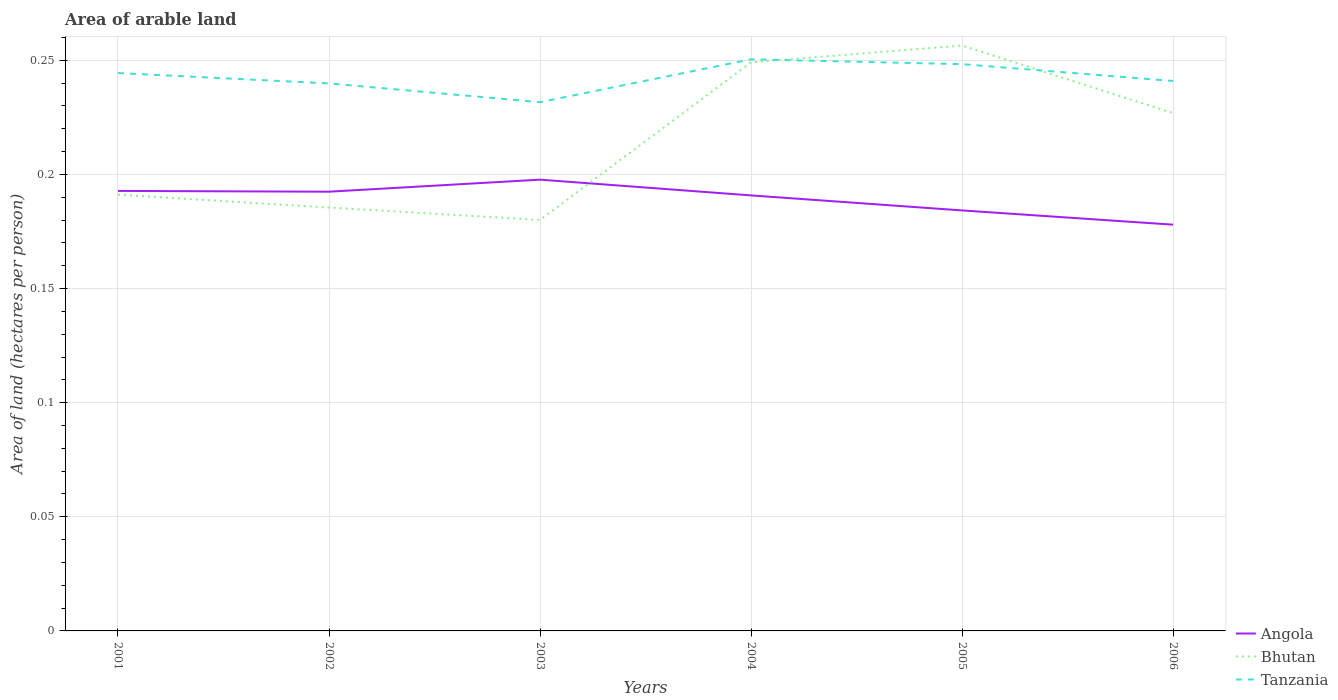Across all years, what is the maximum total arable land in Bhutan?
Your answer should be very brief. 0.18. In which year was the total arable land in Bhutan maximum?
Your answer should be compact. 2003. What is the total total arable land in Bhutan in the graph?
Keep it short and to the point. -0.08. What is the difference between the highest and the second highest total arable land in Bhutan?
Keep it short and to the point. 0.08. How many lines are there?
Offer a very short reply. 3. How many years are there in the graph?
Offer a very short reply. 6. What is the difference between two consecutive major ticks on the Y-axis?
Give a very brief answer. 0.05. Are the values on the major ticks of Y-axis written in scientific E-notation?
Provide a short and direct response. No. Where does the legend appear in the graph?
Ensure brevity in your answer.  Bottom right. How many legend labels are there?
Offer a terse response. 3. What is the title of the graph?
Give a very brief answer. Area of arable land. What is the label or title of the X-axis?
Provide a succinct answer. Years. What is the label or title of the Y-axis?
Ensure brevity in your answer.  Area of land (hectares per person). What is the Area of land (hectares per person) of Angola in 2001?
Ensure brevity in your answer.  0.19. What is the Area of land (hectares per person) in Bhutan in 2001?
Your answer should be very brief. 0.19. What is the Area of land (hectares per person) of Tanzania in 2001?
Provide a short and direct response. 0.24. What is the Area of land (hectares per person) in Angola in 2002?
Provide a succinct answer. 0.19. What is the Area of land (hectares per person) in Bhutan in 2002?
Your answer should be very brief. 0.19. What is the Area of land (hectares per person) of Tanzania in 2002?
Your answer should be compact. 0.24. What is the Area of land (hectares per person) in Angola in 2003?
Your answer should be very brief. 0.2. What is the Area of land (hectares per person) of Bhutan in 2003?
Keep it short and to the point. 0.18. What is the Area of land (hectares per person) in Tanzania in 2003?
Your answer should be compact. 0.23. What is the Area of land (hectares per person) of Angola in 2004?
Provide a short and direct response. 0.19. What is the Area of land (hectares per person) of Bhutan in 2004?
Keep it short and to the point. 0.25. What is the Area of land (hectares per person) of Tanzania in 2004?
Offer a terse response. 0.25. What is the Area of land (hectares per person) of Angola in 2005?
Your response must be concise. 0.18. What is the Area of land (hectares per person) of Bhutan in 2005?
Ensure brevity in your answer.  0.26. What is the Area of land (hectares per person) in Tanzania in 2005?
Provide a succinct answer. 0.25. What is the Area of land (hectares per person) in Angola in 2006?
Offer a terse response. 0.18. What is the Area of land (hectares per person) of Bhutan in 2006?
Keep it short and to the point. 0.23. What is the Area of land (hectares per person) of Tanzania in 2006?
Provide a succinct answer. 0.24. Across all years, what is the maximum Area of land (hectares per person) of Angola?
Make the answer very short. 0.2. Across all years, what is the maximum Area of land (hectares per person) in Bhutan?
Offer a very short reply. 0.26. Across all years, what is the maximum Area of land (hectares per person) of Tanzania?
Offer a very short reply. 0.25. Across all years, what is the minimum Area of land (hectares per person) of Angola?
Ensure brevity in your answer.  0.18. Across all years, what is the minimum Area of land (hectares per person) of Bhutan?
Provide a succinct answer. 0.18. Across all years, what is the minimum Area of land (hectares per person) of Tanzania?
Make the answer very short. 0.23. What is the total Area of land (hectares per person) in Angola in the graph?
Your answer should be very brief. 1.14. What is the total Area of land (hectares per person) of Bhutan in the graph?
Keep it short and to the point. 1.29. What is the total Area of land (hectares per person) of Tanzania in the graph?
Provide a succinct answer. 1.46. What is the difference between the Area of land (hectares per person) of Bhutan in 2001 and that in 2002?
Your answer should be compact. 0.01. What is the difference between the Area of land (hectares per person) in Tanzania in 2001 and that in 2002?
Give a very brief answer. 0. What is the difference between the Area of land (hectares per person) in Angola in 2001 and that in 2003?
Provide a succinct answer. -0. What is the difference between the Area of land (hectares per person) of Bhutan in 2001 and that in 2003?
Offer a terse response. 0.01. What is the difference between the Area of land (hectares per person) in Tanzania in 2001 and that in 2003?
Offer a terse response. 0.01. What is the difference between the Area of land (hectares per person) of Angola in 2001 and that in 2004?
Offer a terse response. 0. What is the difference between the Area of land (hectares per person) of Bhutan in 2001 and that in 2004?
Your answer should be compact. -0.06. What is the difference between the Area of land (hectares per person) of Tanzania in 2001 and that in 2004?
Keep it short and to the point. -0.01. What is the difference between the Area of land (hectares per person) in Angola in 2001 and that in 2005?
Give a very brief answer. 0.01. What is the difference between the Area of land (hectares per person) in Bhutan in 2001 and that in 2005?
Your answer should be very brief. -0.07. What is the difference between the Area of land (hectares per person) in Tanzania in 2001 and that in 2005?
Provide a succinct answer. -0. What is the difference between the Area of land (hectares per person) in Angola in 2001 and that in 2006?
Provide a short and direct response. 0.01. What is the difference between the Area of land (hectares per person) in Bhutan in 2001 and that in 2006?
Your response must be concise. -0.04. What is the difference between the Area of land (hectares per person) in Tanzania in 2001 and that in 2006?
Your answer should be compact. 0. What is the difference between the Area of land (hectares per person) of Angola in 2002 and that in 2003?
Keep it short and to the point. -0.01. What is the difference between the Area of land (hectares per person) of Bhutan in 2002 and that in 2003?
Offer a very short reply. 0.01. What is the difference between the Area of land (hectares per person) of Tanzania in 2002 and that in 2003?
Your response must be concise. 0.01. What is the difference between the Area of land (hectares per person) of Angola in 2002 and that in 2004?
Give a very brief answer. 0. What is the difference between the Area of land (hectares per person) in Bhutan in 2002 and that in 2004?
Keep it short and to the point. -0.06. What is the difference between the Area of land (hectares per person) in Tanzania in 2002 and that in 2004?
Your answer should be compact. -0.01. What is the difference between the Area of land (hectares per person) in Angola in 2002 and that in 2005?
Your response must be concise. 0.01. What is the difference between the Area of land (hectares per person) in Bhutan in 2002 and that in 2005?
Make the answer very short. -0.07. What is the difference between the Area of land (hectares per person) of Tanzania in 2002 and that in 2005?
Offer a very short reply. -0.01. What is the difference between the Area of land (hectares per person) in Angola in 2002 and that in 2006?
Make the answer very short. 0.01. What is the difference between the Area of land (hectares per person) of Bhutan in 2002 and that in 2006?
Ensure brevity in your answer.  -0.04. What is the difference between the Area of land (hectares per person) in Tanzania in 2002 and that in 2006?
Offer a very short reply. -0. What is the difference between the Area of land (hectares per person) of Angola in 2003 and that in 2004?
Your answer should be very brief. 0.01. What is the difference between the Area of land (hectares per person) in Bhutan in 2003 and that in 2004?
Your answer should be very brief. -0.07. What is the difference between the Area of land (hectares per person) of Tanzania in 2003 and that in 2004?
Ensure brevity in your answer.  -0.02. What is the difference between the Area of land (hectares per person) of Angola in 2003 and that in 2005?
Offer a very short reply. 0.01. What is the difference between the Area of land (hectares per person) in Bhutan in 2003 and that in 2005?
Offer a terse response. -0.08. What is the difference between the Area of land (hectares per person) of Tanzania in 2003 and that in 2005?
Give a very brief answer. -0.02. What is the difference between the Area of land (hectares per person) in Angola in 2003 and that in 2006?
Provide a succinct answer. 0.02. What is the difference between the Area of land (hectares per person) of Bhutan in 2003 and that in 2006?
Provide a short and direct response. -0.05. What is the difference between the Area of land (hectares per person) in Tanzania in 2003 and that in 2006?
Provide a succinct answer. -0.01. What is the difference between the Area of land (hectares per person) in Angola in 2004 and that in 2005?
Your answer should be compact. 0.01. What is the difference between the Area of land (hectares per person) of Bhutan in 2004 and that in 2005?
Keep it short and to the point. -0.01. What is the difference between the Area of land (hectares per person) in Tanzania in 2004 and that in 2005?
Ensure brevity in your answer.  0. What is the difference between the Area of land (hectares per person) of Angola in 2004 and that in 2006?
Your answer should be compact. 0.01. What is the difference between the Area of land (hectares per person) in Bhutan in 2004 and that in 2006?
Keep it short and to the point. 0.02. What is the difference between the Area of land (hectares per person) in Tanzania in 2004 and that in 2006?
Your answer should be compact. 0.01. What is the difference between the Area of land (hectares per person) in Angola in 2005 and that in 2006?
Ensure brevity in your answer.  0.01. What is the difference between the Area of land (hectares per person) in Bhutan in 2005 and that in 2006?
Your response must be concise. 0.03. What is the difference between the Area of land (hectares per person) of Tanzania in 2005 and that in 2006?
Ensure brevity in your answer.  0.01. What is the difference between the Area of land (hectares per person) in Angola in 2001 and the Area of land (hectares per person) in Bhutan in 2002?
Keep it short and to the point. 0.01. What is the difference between the Area of land (hectares per person) of Angola in 2001 and the Area of land (hectares per person) of Tanzania in 2002?
Make the answer very short. -0.05. What is the difference between the Area of land (hectares per person) of Bhutan in 2001 and the Area of land (hectares per person) of Tanzania in 2002?
Offer a very short reply. -0.05. What is the difference between the Area of land (hectares per person) of Angola in 2001 and the Area of land (hectares per person) of Bhutan in 2003?
Ensure brevity in your answer.  0.01. What is the difference between the Area of land (hectares per person) in Angola in 2001 and the Area of land (hectares per person) in Tanzania in 2003?
Your response must be concise. -0.04. What is the difference between the Area of land (hectares per person) of Bhutan in 2001 and the Area of land (hectares per person) of Tanzania in 2003?
Your answer should be compact. -0.04. What is the difference between the Area of land (hectares per person) of Angola in 2001 and the Area of land (hectares per person) of Bhutan in 2004?
Make the answer very short. -0.06. What is the difference between the Area of land (hectares per person) of Angola in 2001 and the Area of land (hectares per person) of Tanzania in 2004?
Give a very brief answer. -0.06. What is the difference between the Area of land (hectares per person) in Bhutan in 2001 and the Area of land (hectares per person) in Tanzania in 2004?
Offer a terse response. -0.06. What is the difference between the Area of land (hectares per person) in Angola in 2001 and the Area of land (hectares per person) in Bhutan in 2005?
Your answer should be compact. -0.06. What is the difference between the Area of land (hectares per person) of Angola in 2001 and the Area of land (hectares per person) of Tanzania in 2005?
Provide a succinct answer. -0.06. What is the difference between the Area of land (hectares per person) of Bhutan in 2001 and the Area of land (hectares per person) of Tanzania in 2005?
Offer a very short reply. -0.06. What is the difference between the Area of land (hectares per person) of Angola in 2001 and the Area of land (hectares per person) of Bhutan in 2006?
Your answer should be compact. -0.03. What is the difference between the Area of land (hectares per person) of Angola in 2001 and the Area of land (hectares per person) of Tanzania in 2006?
Offer a terse response. -0.05. What is the difference between the Area of land (hectares per person) in Bhutan in 2001 and the Area of land (hectares per person) in Tanzania in 2006?
Offer a very short reply. -0.05. What is the difference between the Area of land (hectares per person) in Angola in 2002 and the Area of land (hectares per person) in Bhutan in 2003?
Provide a short and direct response. 0.01. What is the difference between the Area of land (hectares per person) of Angola in 2002 and the Area of land (hectares per person) of Tanzania in 2003?
Offer a terse response. -0.04. What is the difference between the Area of land (hectares per person) of Bhutan in 2002 and the Area of land (hectares per person) of Tanzania in 2003?
Offer a terse response. -0.05. What is the difference between the Area of land (hectares per person) of Angola in 2002 and the Area of land (hectares per person) of Bhutan in 2004?
Your response must be concise. -0.06. What is the difference between the Area of land (hectares per person) of Angola in 2002 and the Area of land (hectares per person) of Tanzania in 2004?
Give a very brief answer. -0.06. What is the difference between the Area of land (hectares per person) of Bhutan in 2002 and the Area of land (hectares per person) of Tanzania in 2004?
Keep it short and to the point. -0.06. What is the difference between the Area of land (hectares per person) in Angola in 2002 and the Area of land (hectares per person) in Bhutan in 2005?
Your answer should be very brief. -0.06. What is the difference between the Area of land (hectares per person) of Angola in 2002 and the Area of land (hectares per person) of Tanzania in 2005?
Keep it short and to the point. -0.06. What is the difference between the Area of land (hectares per person) of Bhutan in 2002 and the Area of land (hectares per person) of Tanzania in 2005?
Keep it short and to the point. -0.06. What is the difference between the Area of land (hectares per person) in Angola in 2002 and the Area of land (hectares per person) in Bhutan in 2006?
Make the answer very short. -0.03. What is the difference between the Area of land (hectares per person) of Angola in 2002 and the Area of land (hectares per person) of Tanzania in 2006?
Your answer should be compact. -0.05. What is the difference between the Area of land (hectares per person) of Bhutan in 2002 and the Area of land (hectares per person) of Tanzania in 2006?
Your response must be concise. -0.06. What is the difference between the Area of land (hectares per person) of Angola in 2003 and the Area of land (hectares per person) of Bhutan in 2004?
Provide a short and direct response. -0.05. What is the difference between the Area of land (hectares per person) of Angola in 2003 and the Area of land (hectares per person) of Tanzania in 2004?
Your response must be concise. -0.05. What is the difference between the Area of land (hectares per person) of Bhutan in 2003 and the Area of land (hectares per person) of Tanzania in 2004?
Provide a succinct answer. -0.07. What is the difference between the Area of land (hectares per person) in Angola in 2003 and the Area of land (hectares per person) in Bhutan in 2005?
Give a very brief answer. -0.06. What is the difference between the Area of land (hectares per person) in Angola in 2003 and the Area of land (hectares per person) in Tanzania in 2005?
Your answer should be compact. -0.05. What is the difference between the Area of land (hectares per person) in Bhutan in 2003 and the Area of land (hectares per person) in Tanzania in 2005?
Provide a succinct answer. -0.07. What is the difference between the Area of land (hectares per person) in Angola in 2003 and the Area of land (hectares per person) in Bhutan in 2006?
Provide a short and direct response. -0.03. What is the difference between the Area of land (hectares per person) in Angola in 2003 and the Area of land (hectares per person) in Tanzania in 2006?
Provide a short and direct response. -0.04. What is the difference between the Area of land (hectares per person) in Bhutan in 2003 and the Area of land (hectares per person) in Tanzania in 2006?
Ensure brevity in your answer.  -0.06. What is the difference between the Area of land (hectares per person) of Angola in 2004 and the Area of land (hectares per person) of Bhutan in 2005?
Offer a very short reply. -0.07. What is the difference between the Area of land (hectares per person) in Angola in 2004 and the Area of land (hectares per person) in Tanzania in 2005?
Give a very brief answer. -0.06. What is the difference between the Area of land (hectares per person) of Bhutan in 2004 and the Area of land (hectares per person) of Tanzania in 2005?
Your answer should be compact. 0. What is the difference between the Area of land (hectares per person) of Angola in 2004 and the Area of land (hectares per person) of Bhutan in 2006?
Provide a succinct answer. -0.04. What is the difference between the Area of land (hectares per person) of Angola in 2004 and the Area of land (hectares per person) of Tanzania in 2006?
Make the answer very short. -0.05. What is the difference between the Area of land (hectares per person) in Bhutan in 2004 and the Area of land (hectares per person) in Tanzania in 2006?
Keep it short and to the point. 0.01. What is the difference between the Area of land (hectares per person) of Angola in 2005 and the Area of land (hectares per person) of Bhutan in 2006?
Offer a very short reply. -0.04. What is the difference between the Area of land (hectares per person) in Angola in 2005 and the Area of land (hectares per person) in Tanzania in 2006?
Your answer should be very brief. -0.06. What is the difference between the Area of land (hectares per person) in Bhutan in 2005 and the Area of land (hectares per person) in Tanzania in 2006?
Offer a very short reply. 0.02. What is the average Area of land (hectares per person) of Angola per year?
Provide a succinct answer. 0.19. What is the average Area of land (hectares per person) of Bhutan per year?
Your answer should be very brief. 0.21. What is the average Area of land (hectares per person) of Tanzania per year?
Your answer should be very brief. 0.24. In the year 2001, what is the difference between the Area of land (hectares per person) in Angola and Area of land (hectares per person) in Bhutan?
Your answer should be compact. 0. In the year 2001, what is the difference between the Area of land (hectares per person) of Angola and Area of land (hectares per person) of Tanzania?
Your answer should be very brief. -0.05. In the year 2001, what is the difference between the Area of land (hectares per person) of Bhutan and Area of land (hectares per person) of Tanzania?
Make the answer very short. -0.05. In the year 2002, what is the difference between the Area of land (hectares per person) of Angola and Area of land (hectares per person) of Bhutan?
Offer a terse response. 0.01. In the year 2002, what is the difference between the Area of land (hectares per person) in Angola and Area of land (hectares per person) in Tanzania?
Ensure brevity in your answer.  -0.05. In the year 2002, what is the difference between the Area of land (hectares per person) in Bhutan and Area of land (hectares per person) in Tanzania?
Provide a short and direct response. -0.05. In the year 2003, what is the difference between the Area of land (hectares per person) in Angola and Area of land (hectares per person) in Bhutan?
Make the answer very short. 0.02. In the year 2003, what is the difference between the Area of land (hectares per person) in Angola and Area of land (hectares per person) in Tanzania?
Provide a succinct answer. -0.03. In the year 2003, what is the difference between the Area of land (hectares per person) in Bhutan and Area of land (hectares per person) in Tanzania?
Provide a short and direct response. -0.05. In the year 2004, what is the difference between the Area of land (hectares per person) of Angola and Area of land (hectares per person) of Bhutan?
Offer a very short reply. -0.06. In the year 2004, what is the difference between the Area of land (hectares per person) of Angola and Area of land (hectares per person) of Tanzania?
Your answer should be very brief. -0.06. In the year 2004, what is the difference between the Area of land (hectares per person) in Bhutan and Area of land (hectares per person) in Tanzania?
Give a very brief answer. -0. In the year 2005, what is the difference between the Area of land (hectares per person) in Angola and Area of land (hectares per person) in Bhutan?
Your answer should be compact. -0.07. In the year 2005, what is the difference between the Area of land (hectares per person) in Angola and Area of land (hectares per person) in Tanzania?
Give a very brief answer. -0.06. In the year 2005, what is the difference between the Area of land (hectares per person) of Bhutan and Area of land (hectares per person) of Tanzania?
Provide a short and direct response. 0.01. In the year 2006, what is the difference between the Area of land (hectares per person) of Angola and Area of land (hectares per person) of Bhutan?
Make the answer very short. -0.05. In the year 2006, what is the difference between the Area of land (hectares per person) of Angola and Area of land (hectares per person) of Tanzania?
Offer a very short reply. -0.06. In the year 2006, what is the difference between the Area of land (hectares per person) of Bhutan and Area of land (hectares per person) of Tanzania?
Give a very brief answer. -0.01. What is the ratio of the Area of land (hectares per person) of Bhutan in 2001 to that in 2002?
Keep it short and to the point. 1.03. What is the ratio of the Area of land (hectares per person) of Tanzania in 2001 to that in 2002?
Your answer should be very brief. 1.02. What is the ratio of the Area of land (hectares per person) of Bhutan in 2001 to that in 2003?
Your answer should be very brief. 1.06. What is the ratio of the Area of land (hectares per person) of Tanzania in 2001 to that in 2003?
Offer a terse response. 1.06. What is the ratio of the Area of land (hectares per person) of Angola in 2001 to that in 2004?
Give a very brief answer. 1.01. What is the ratio of the Area of land (hectares per person) in Bhutan in 2001 to that in 2004?
Ensure brevity in your answer.  0.77. What is the ratio of the Area of land (hectares per person) of Angola in 2001 to that in 2005?
Your response must be concise. 1.05. What is the ratio of the Area of land (hectares per person) of Bhutan in 2001 to that in 2005?
Your answer should be very brief. 0.75. What is the ratio of the Area of land (hectares per person) of Tanzania in 2001 to that in 2005?
Give a very brief answer. 0.98. What is the ratio of the Area of land (hectares per person) of Angola in 2001 to that in 2006?
Your response must be concise. 1.08. What is the ratio of the Area of land (hectares per person) of Bhutan in 2001 to that in 2006?
Keep it short and to the point. 0.84. What is the ratio of the Area of land (hectares per person) of Tanzania in 2001 to that in 2006?
Your answer should be very brief. 1.01. What is the ratio of the Area of land (hectares per person) of Angola in 2002 to that in 2003?
Your answer should be compact. 0.97. What is the ratio of the Area of land (hectares per person) in Bhutan in 2002 to that in 2003?
Offer a terse response. 1.03. What is the ratio of the Area of land (hectares per person) in Tanzania in 2002 to that in 2003?
Ensure brevity in your answer.  1.04. What is the ratio of the Area of land (hectares per person) in Angola in 2002 to that in 2004?
Make the answer very short. 1.01. What is the ratio of the Area of land (hectares per person) in Bhutan in 2002 to that in 2004?
Provide a succinct answer. 0.74. What is the ratio of the Area of land (hectares per person) of Tanzania in 2002 to that in 2004?
Give a very brief answer. 0.96. What is the ratio of the Area of land (hectares per person) of Angola in 2002 to that in 2005?
Ensure brevity in your answer.  1.04. What is the ratio of the Area of land (hectares per person) in Bhutan in 2002 to that in 2005?
Your response must be concise. 0.72. What is the ratio of the Area of land (hectares per person) of Angola in 2002 to that in 2006?
Provide a short and direct response. 1.08. What is the ratio of the Area of land (hectares per person) of Bhutan in 2002 to that in 2006?
Make the answer very short. 0.82. What is the ratio of the Area of land (hectares per person) of Angola in 2003 to that in 2004?
Provide a short and direct response. 1.04. What is the ratio of the Area of land (hectares per person) of Bhutan in 2003 to that in 2004?
Your answer should be compact. 0.72. What is the ratio of the Area of land (hectares per person) of Tanzania in 2003 to that in 2004?
Give a very brief answer. 0.93. What is the ratio of the Area of land (hectares per person) in Angola in 2003 to that in 2005?
Offer a very short reply. 1.07. What is the ratio of the Area of land (hectares per person) in Bhutan in 2003 to that in 2005?
Provide a succinct answer. 0.7. What is the ratio of the Area of land (hectares per person) in Tanzania in 2003 to that in 2005?
Ensure brevity in your answer.  0.93. What is the ratio of the Area of land (hectares per person) in Angola in 2003 to that in 2006?
Make the answer very short. 1.11. What is the ratio of the Area of land (hectares per person) of Bhutan in 2003 to that in 2006?
Provide a short and direct response. 0.79. What is the ratio of the Area of land (hectares per person) in Tanzania in 2003 to that in 2006?
Your answer should be very brief. 0.96. What is the ratio of the Area of land (hectares per person) in Angola in 2004 to that in 2005?
Ensure brevity in your answer.  1.04. What is the ratio of the Area of land (hectares per person) of Bhutan in 2004 to that in 2005?
Your answer should be compact. 0.97. What is the ratio of the Area of land (hectares per person) in Tanzania in 2004 to that in 2005?
Offer a very short reply. 1.01. What is the ratio of the Area of land (hectares per person) of Angola in 2004 to that in 2006?
Give a very brief answer. 1.07. What is the ratio of the Area of land (hectares per person) in Bhutan in 2004 to that in 2006?
Your answer should be compact. 1.1. What is the ratio of the Area of land (hectares per person) in Tanzania in 2004 to that in 2006?
Make the answer very short. 1.04. What is the ratio of the Area of land (hectares per person) in Angola in 2005 to that in 2006?
Your answer should be compact. 1.04. What is the ratio of the Area of land (hectares per person) in Bhutan in 2005 to that in 2006?
Your response must be concise. 1.13. What is the ratio of the Area of land (hectares per person) of Tanzania in 2005 to that in 2006?
Provide a short and direct response. 1.03. What is the difference between the highest and the second highest Area of land (hectares per person) in Angola?
Make the answer very short. 0. What is the difference between the highest and the second highest Area of land (hectares per person) of Bhutan?
Your response must be concise. 0.01. What is the difference between the highest and the second highest Area of land (hectares per person) in Tanzania?
Provide a succinct answer. 0. What is the difference between the highest and the lowest Area of land (hectares per person) of Angola?
Provide a succinct answer. 0.02. What is the difference between the highest and the lowest Area of land (hectares per person) in Bhutan?
Keep it short and to the point. 0.08. What is the difference between the highest and the lowest Area of land (hectares per person) in Tanzania?
Your response must be concise. 0.02. 